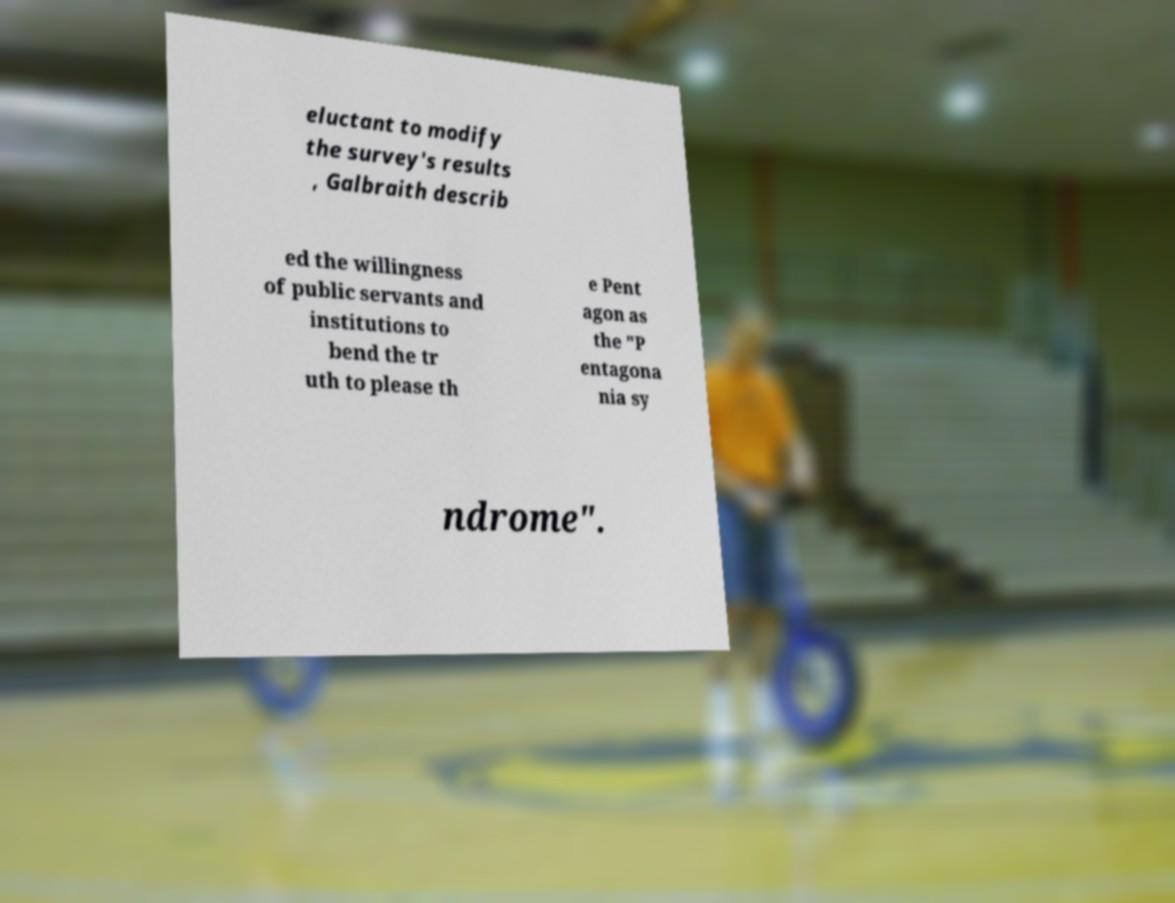Can you read and provide the text displayed in the image?This photo seems to have some interesting text. Can you extract and type it out for me? eluctant to modify the survey's results , Galbraith describ ed the willingness of public servants and institutions to bend the tr uth to please th e Pent agon as the "P entagona nia sy ndrome". 